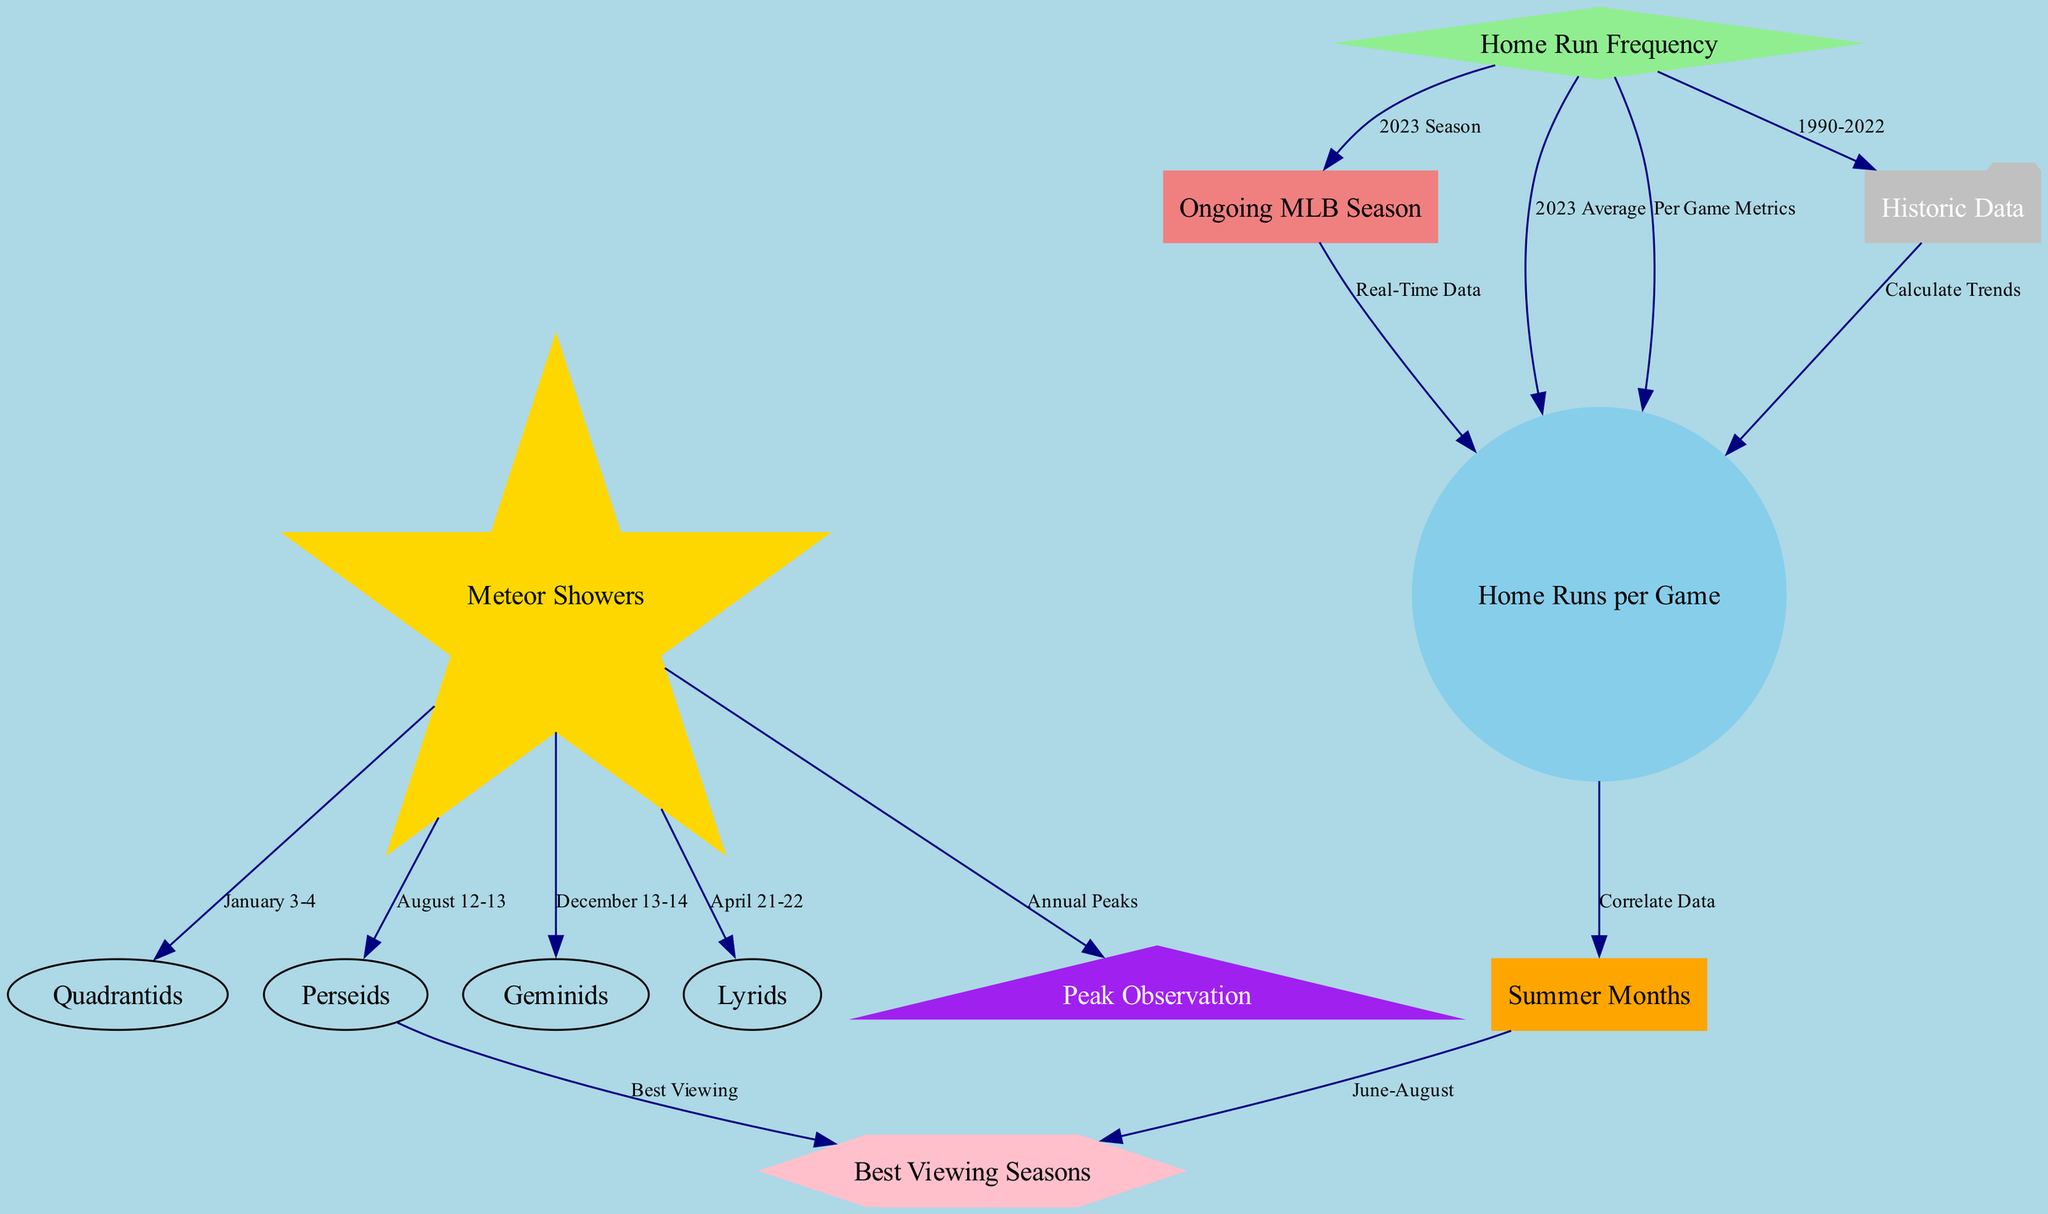What are the Quadrantids? The Quadrantids are listed in the diagram as a type of meteor shower, specifically indicated as connected to the node labeled "Meteor Showers."
Answer: Quadrantids Which month has the best viewing for the Perseids? The diagram states that the Perseids have peak observations during August 12-13, linked to the "Best Viewing Seasons" node.
Answer: August How many total nodes are present in the diagram? By counting each unique labeled node in the diagram, which are "Meteor Showers", "Home Run Frequency", "Quadrantids", "Perseids", "Geminids", "Lyrids", "Summer Months", "Ongoing MLB Season", "Home Runs per Game", "Historic Data", "Peak Observation", and "Best Viewing Seasons", we find there are 12 nodes in total.
Answer: 12 What does "Home Runs per Game" correlate with? The "Home Runs per Game" node is connected to both "Correlate Data" and "2023 Average," indicating these are factors it relates to in the diagram.
Answer: Summer Months When do the Lyrids occur? The Lyrids are connected to the "Meteor Showers" node, and their occurrence is labeled as April 21-22 in the diagram.
Answer: April 21-22 What is the connection between "Historic Data" and "Home Runs per Game"? The diagram shows that "Historic Data" directly connects to "Home Runs per Game" with the relationship labeled as "Calculate Trends," indicating that trends in home runs can be calculated based on this historic data.
Answer: Calculate Trends What are the best viewing seasons indicated in the diagram? Following the connections from the "Best Viewing Seasons" node, it specifically references the correlation to the summer months as the ideal times for meteor shower viewing.
Answer: June-August During which months does the MLB season typically correlate with peak home run frequency? The diagram highlights that the correlation with "Home Runs per Game" specifically points to summer months as the time when frequency peaks, primarily during the ongoing MLB season.
Answer: Summer Months What is the peak observation label connected to? The node labeled "Peak Observation" is linked from "Meteor Showers" under the section labeled "Annual Peaks," pointing to different meteor showers occurring throughout the year.
Answer: Annual Peaks 